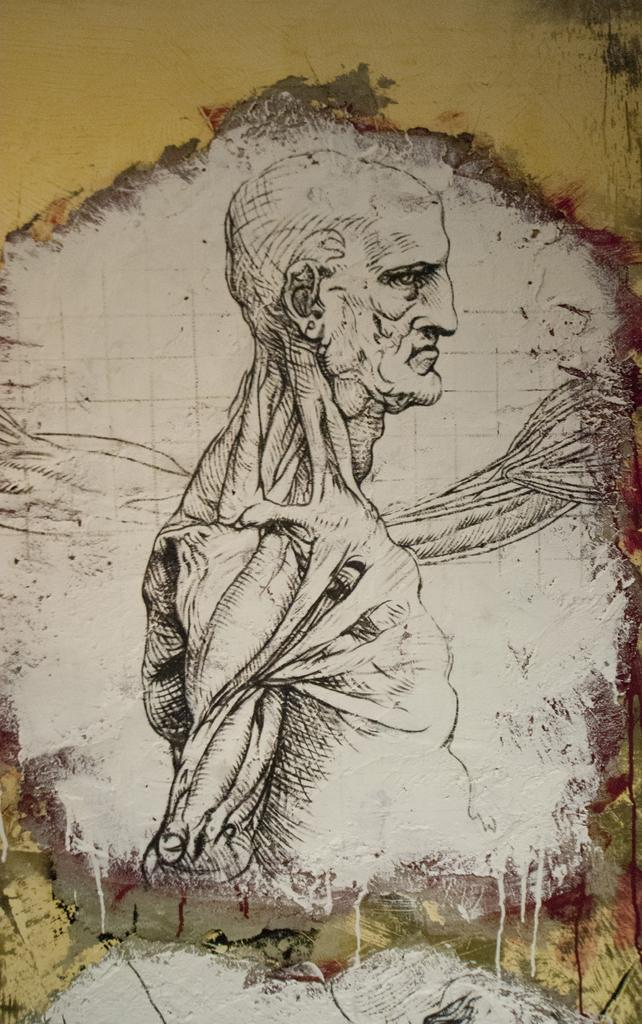What is the main subject of the image? The main subject of the image is an art of a man. What type of glass is the man holding in the image? There is no glass present in the image; it features an art of a man. 